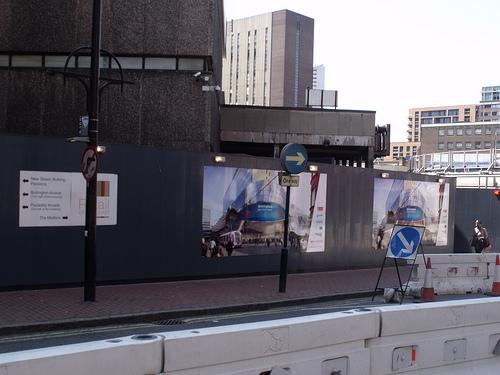How many traffic cones are there and what color are they? There are two blue traffic cones. What is the person in the image doing? The person is walking down a brick sidewalk. Identify one notable feature of the building visible in the image. The building has many windows. What object is hanging from the black iron lamp post? A white and red sign is hanging from the black iron lamp post. Describe the wall on which the poster is placed. The wall is grey and beside a sidewalk. Mention the type of place where the scene takes place. The scene takes place outdoors. Describe one unique aspect of the sidewalk in the image. The sidewalk is made of red cobblestones. Provide a brief description of the construction barriers in the image. There is a gray construction barrier and a white temporary barrier wall. What color is the arrow on the sign? The arrow on the sign is white. List the colors of the sign on the grey wall. Blue and white. 